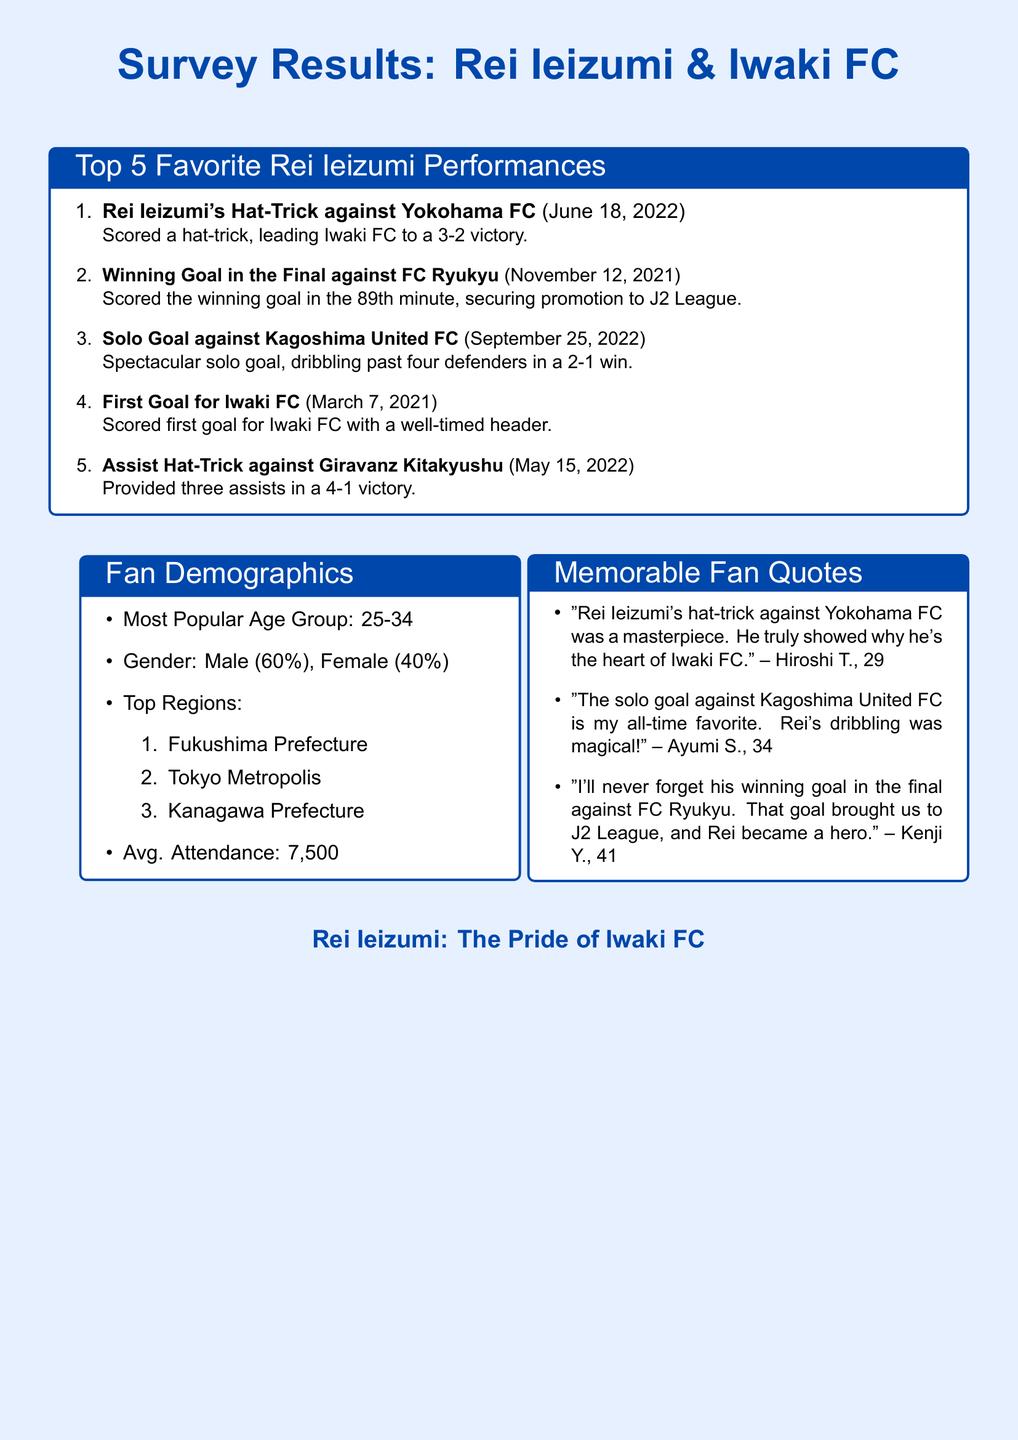What is Rei Ieizumi's most memorable performance? The document lists the top five performances, with the hat-trick against Yokohama FC being the most notable.
Answer: Rei Ieizumi's Hat-Trick against Yokohama FC When did Rei Ieizumi score his first goal for Iwaki FC? The document provides the date for Rei's first goal for Iwaki FC, which is specified as March 7, 2021.
Answer: March 7, 2021 What percentage of the fans are male? The gender demographics indicate that 60% of the fans are male, as mentioned in the document.
Answer: 60% Which age group is the most popular among fans? The document states that the most popular age group among fans is 25-34.
Answer: 25-34 What was the final score of the match where Rei Ieizumi scored a hat-trick against Yokohama FC? The document reports that Iwaki FC won the match 3-2 due to Rei's hat-trick.
Answer: 3-2 Which region has the top attendance average? The average attendance noted in the document is 7,500 for Iwaki FC games.
Answer: 7,500 Who is quoted as calling Rei's solo goal "magical"? The document attributes this quote to Ayumi S., who expressed admiration for Rei's solo goal.
Answer: Ayumi S What year did Rei Ieizumi secure promotion to the J2 League? The document indicates that the promotion was secured on November 12, 2021, with a winning goal by Rei.
Answer: 2021 What is the average attendance mentioned in the document? The average attendance for the fans of Iwaki FC is provided as a specific number.
Answer: 7,500 